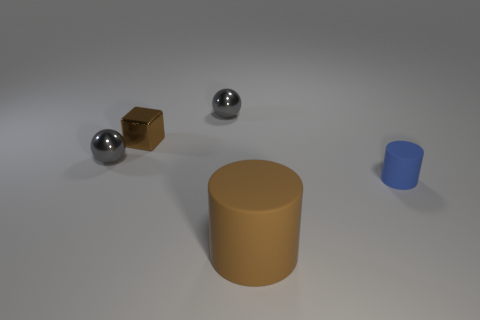Add 2 tiny brown things. How many objects exist? 7 Subtract 2 cylinders. How many cylinders are left? 0 Subtract all yellow cylinders. How many gray cubes are left? 0 Subtract all balls. Subtract all tiny metallic cubes. How many objects are left? 2 Add 2 tiny gray metal spheres. How many tiny gray metal spheres are left? 4 Add 1 tiny cyan objects. How many tiny cyan objects exist? 1 Subtract 0 gray blocks. How many objects are left? 5 Subtract all spheres. How many objects are left? 3 Subtract all gray cylinders. Subtract all purple blocks. How many cylinders are left? 2 